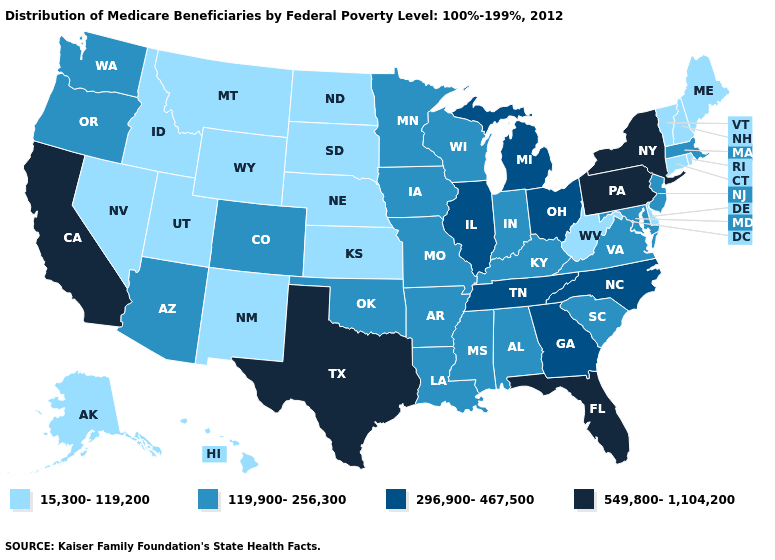What is the lowest value in the USA?
Write a very short answer. 15,300-119,200. Name the states that have a value in the range 15,300-119,200?
Keep it brief. Alaska, Connecticut, Delaware, Hawaii, Idaho, Kansas, Maine, Montana, Nebraska, Nevada, New Hampshire, New Mexico, North Dakota, Rhode Island, South Dakota, Utah, Vermont, West Virginia, Wyoming. What is the value of Nebraska?
Keep it brief. 15,300-119,200. What is the value of South Carolina?
Write a very short answer. 119,900-256,300. Name the states that have a value in the range 549,800-1,104,200?
Keep it brief. California, Florida, New York, Pennsylvania, Texas. Does Minnesota have the highest value in the MidWest?
Be succinct. No. Is the legend a continuous bar?
Keep it brief. No. What is the lowest value in the MidWest?
Answer briefly. 15,300-119,200. What is the lowest value in states that border Illinois?
Write a very short answer. 119,900-256,300. What is the lowest value in the MidWest?
Give a very brief answer. 15,300-119,200. Does Kentucky have the same value as Kansas?
Be succinct. No. Does Arkansas have a higher value than Vermont?
Answer briefly. Yes. What is the value of Virginia?
Short answer required. 119,900-256,300. Does Minnesota have a lower value than Kentucky?
Be succinct. No. Does the first symbol in the legend represent the smallest category?
Keep it brief. Yes. 